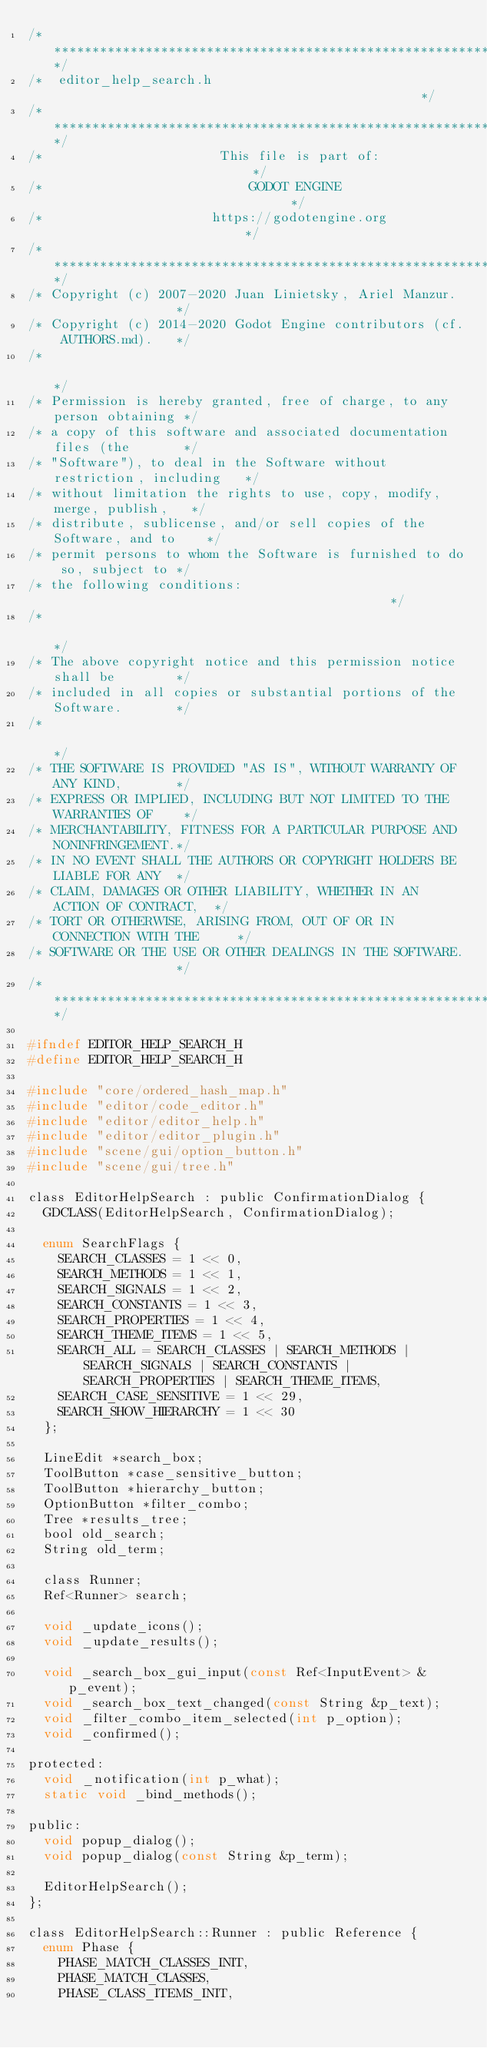<code> <loc_0><loc_0><loc_500><loc_500><_C_>/*************************************************************************/
/*  editor_help_search.h                                                 */
/*************************************************************************/
/*                       This file is part of:                           */
/*                           GODOT ENGINE                                */
/*                      https://godotengine.org                          */
/*************************************************************************/
/* Copyright (c) 2007-2020 Juan Linietsky, Ariel Manzur.                 */
/* Copyright (c) 2014-2020 Godot Engine contributors (cf. AUTHORS.md).   */
/*                                                                       */
/* Permission is hereby granted, free of charge, to any person obtaining */
/* a copy of this software and associated documentation files (the       */
/* "Software"), to deal in the Software without restriction, including   */
/* without limitation the rights to use, copy, modify, merge, publish,   */
/* distribute, sublicense, and/or sell copies of the Software, and to    */
/* permit persons to whom the Software is furnished to do so, subject to */
/* the following conditions:                                             */
/*                                                                       */
/* The above copyright notice and this permission notice shall be        */
/* included in all copies or substantial portions of the Software.       */
/*                                                                       */
/* THE SOFTWARE IS PROVIDED "AS IS", WITHOUT WARRANTY OF ANY KIND,       */
/* EXPRESS OR IMPLIED, INCLUDING BUT NOT LIMITED TO THE WARRANTIES OF    */
/* MERCHANTABILITY, FITNESS FOR A PARTICULAR PURPOSE AND NONINFRINGEMENT.*/
/* IN NO EVENT SHALL THE AUTHORS OR COPYRIGHT HOLDERS BE LIABLE FOR ANY  */
/* CLAIM, DAMAGES OR OTHER LIABILITY, WHETHER IN AN ACTION OF CONTRACT,  */
/* TORT OR OTHERWISE, ARISING FROM, OUT OF OR IN CONNECTION WITH THE     */
/* SOFTWARE OR THE USE OR OTHER DEALINGS IN THE SOFTWARE.                */
/*************************************************************************/

#ifndef EDITOR_HELP_SEARCH_H
#define EDITOR_HELP_SEARCH_H

#include "core/ordered_hash_map.h"
#include "editor/code_editor.h"
#include "editor/editor_help.h"
#include "editor/editor_plugin.h"
#include "scene/gui/option_button.h"
#include "scene/gui/tree.h"

class EditorHelpSearch : public ConfirmationDialog {
	GDCLASS(EditorHelpSearch, ConfirmationDialog);

	enum SearchFlags {
		SEARCH_CLASSES = 1 << 0,
		SEARCH_METHODS = 1 << 1,
		SEARCH_SIGNALS = 1 << 2,
		SEARCH_CONSTANTS = 1 << 3,
		SEARCH_PROPERTIES = 1 << 4,
		SEARCH_THEME_ITEMS = 1 << 5,
		SEARCH_ALL = SEARCH_CLASSES | SEARCH_METHODS | SEARCH_SIGNALS | SEARCH_CONSTANTS | SEARCH_PROPERTIES | SEARCH_THEME_ITEMS,
		SEARCH_CASE_SENSITIVE = 1 << 29,
		SEARCH_SHOW_HIERARCHY = 1 << 30
	};

	LineEdit *search_box;
	ToolButton *case_sensitive_button;
	ToolButton *hierarchy_button;
	OptionButton *filter_combo;
	Tree *results_tree;
	bool old_search;
	String old_term;

	class Runner;
	Ref<Runner> search;

	void _update_icons();
	void _update_results();

	void _search_box_gui_input(const Ref<InputEvent> &p_event);
	void _search_box_text_changed(const String &p_text);
	void _filter_combo_item_selected(int p_option);
	void _confirmed();

protected:
	void _notification(int p_what);
	static void _bind_methods();

public:
	void popup_dialog();
	void popup_dialog(const String &p_term);

	EditorHelpSearch();
};

class EditorHelpSearch::Runner : public Reference {
	enum Phase {
		PHASE_MATCH_CLASSES_INIT,
		PHASE_MATCH_CLASSES,
		PHASE_CLASS_ITEMS_INIT,</code> 